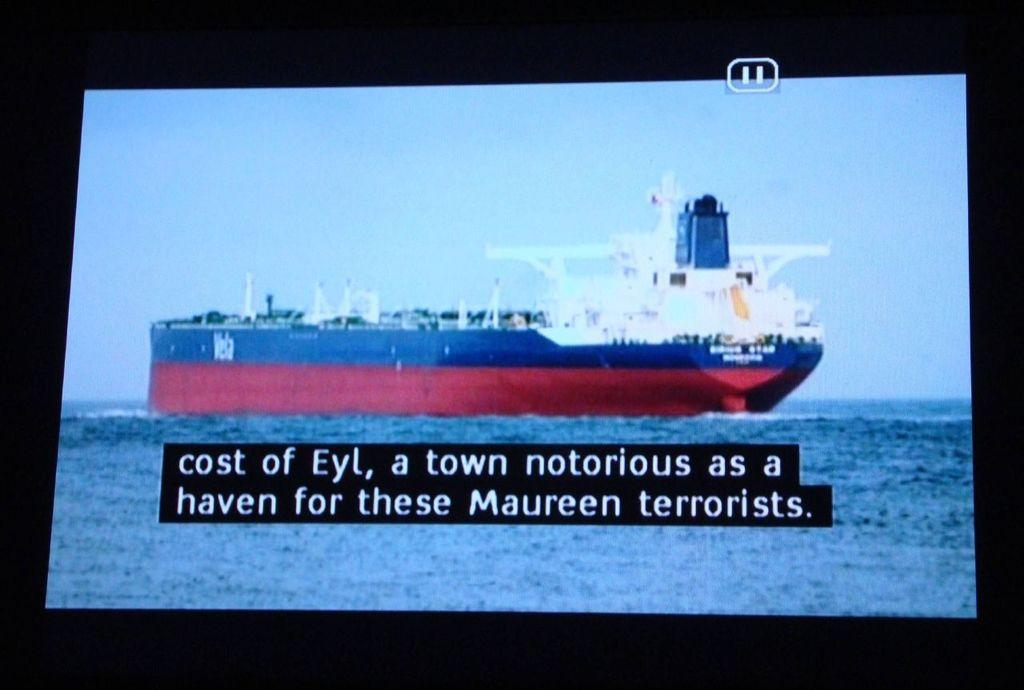<image>
Relay a brief, clear account of the picture shown. Large blue and red ship with captions about the cost of Eyl 